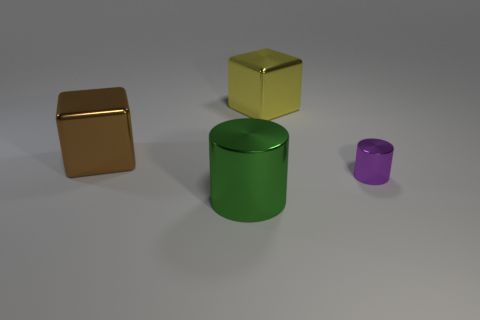How many cylinders are either big green shiny things or yellow metal objects?
Offer a terse response. 1. There is a block that is to the right of the shiny cylinder left of the big thing that is behind the big brown shiny object; what is its size?
Your response must be concise. Large. There is a yellow shiny thing that is the same shape as the brown metallic thing; what is its size?
Ensure brevity in your answer.  Large. How many big objects are on the left side of the yellow block?
Your answer should be very brief. 2. There is a big metallic object in front of the big brown metal cube; is it the same color as the small object?
Your answer should be very brief. No. What number of purple objects are metal cubes or cylinders?
Your response must be concise. 1. What is the color of the big cube that is in front of the large metallic block behind the brown thing?
Offer a very short reply. Brown. What color is the large metal block left of the big green object?
Provide a short and direct response. Brown. Does the cylinder to the left of the purple shiny object have the same size as the tiny shiny cylinder?
Offer a terse response. No. Is there a purple metal object of the same size as the brown cube?
Give a very brief answer. No. 